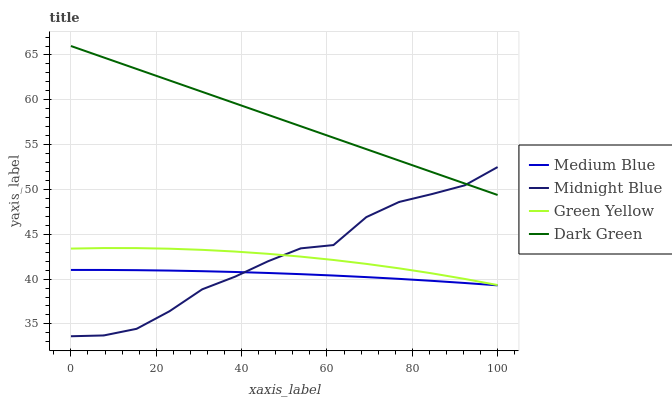Does Medium Blue have the minimum area under the curve?
Answer yes or no. Yes. Does Dark Green have the maximum area under the curve?
Answer yes or no. Yes. Does Midnight Blue have the minimum area under the curve?
Answer yes or no. No. Does Midnight Blue have the maximum area under the curve?
Answer yes or no. No. Is Dark Green the smoothest?
Answer yes or no. Yes. Is Midnight Blue the roughest?
Answer yes or no. Yes. Is Medium Blue the smoothest?
Answer yes or no. No. Is Medium Blue the roughest?
Answer yes or no. No. Does Midnight Blue have the lowest value?
Answer yes or no. Yes. Does Medium Blue have the lowest value?
Answer yes or no. No. Does Dark Green have the highest value?
Answer yes or no. Yes. Does Midnight Blue have the highest value?
Answer yes or no. No. Is Medium Blue less than Dark Green?
Answer yes or no. Yes. Is Dark Green greater than Green Yellow?
Answer yes or no. Yes. Does Midnight Blue intersect Dark Green?
Answer yes or no. Yes. Is Midnight Blue less than Dark Green?
Answer yes or no. No. Is Midnight Blue greater than Dark Green?
Answer yes or no. No. Does Medium Blue intersect Dark Green?
Answer yes or no. No. 